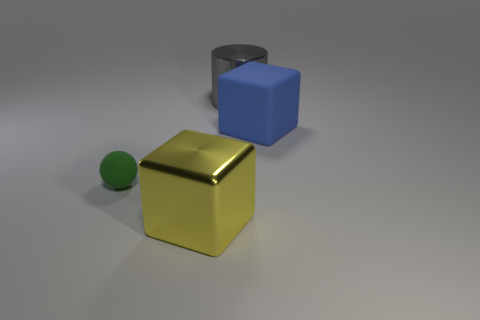There is a matte thing in front of the large rubber block; how many matte cubes are in front of it?
Give a very brief answer. 0. What is the shape of the thing that is both to the right of the tiny green thing and on the left side of the gray cylinder?
Offer a terse response. Cube. How many matte things have the same color as the rubber sphere?
Make the answer very short. 0. Are there any green balls on the right side of the blue block behind the big cube left of the large cylinder?
Ensure brevity in your answer.  No. There is a thing that is both to the right of the tiny green object and left of the gray metallic cylinder; how big is it?
Offer a very short reply. Large. What number of gray objects have the same material as the yellow thing?
Make the answer very short. 1. What number of cylinders are either large objects or matte objects?
Your answer should be compact. 1. What size is the cube behind the big metallic object that is on the left side of the shiny thing right of the yellow cube?
Give a very brief answer. Large. What is the color of the object that is behind the small rubber object and in front of the gray metal cylinder?
Ensure brevity in your answer.  Blue. Do the yellow shiny cube and the block to the right of the large shiny cylinder have the same size?
Give a very brief answer. Yes. 